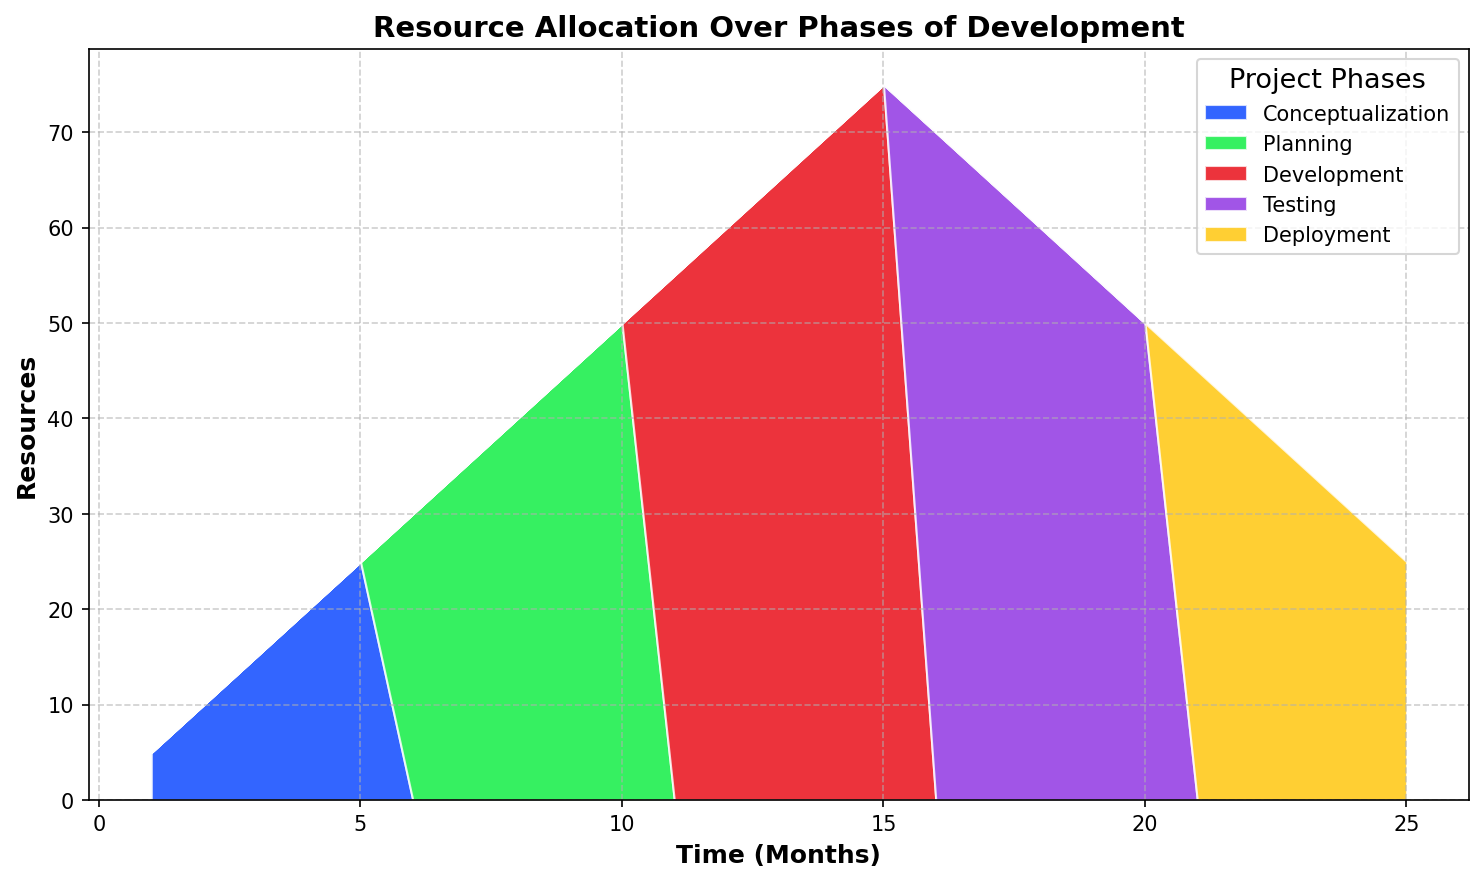What is the maximum resource allocation during the Conceptualization phase? The Conceptualization phase's resources increase from 5 to 25 over time. The maximum value occurs at the last point of this phase.
Answer: 25 Which phase has the highest peak in resource allocation? To determine this, look for the highest point in the area chart. The Development phase peaks at 75.
Answer: Development During which time range does the Planning phase occur? The Planning phase starts at 6 months and ends at 10 months, based on the color-coded segments.
Answer: 6-10 months What's the difference in resource allocation between the peak of the Planning phase and the start of the Deployment phase? Planning peaks at 50 resources and Deployment starts at 45 resources, so the difference is 50 - 45.
Answer: 5 During which phase do resources start to decline? The area for Testing shows a decline starting at 16 months.
Answer: Testing How does resource allocation change over the Development phase? Resources for the Development phase increase from 55 to 75 over the time period shown.
Answer: Increase from 55 to 75 Compare the resource allocation at the start of Planning and the end of Deployment. Which is greater? Planning starts at 30 resources, and Deployment ends at 25 resources; 30 is greater than 25.
Answer: Planning What is the total resource allocation at 15 months? At 15 months, only the Development phase is active with 75 resources.
Answer: 75 How does the resource allocation change from the end of Testing to the start of Deployment? Testing ends at 50 resources, and Deployment starts at 45 resources, so it drops by 5.
Answer: Drops by 5 Which phase has the most consistent resource allocation over its duration? Conceptualization shows a steady increase, but Testing remains stable around 70 to 50 resources without fluctuation.
Answer: Testing 